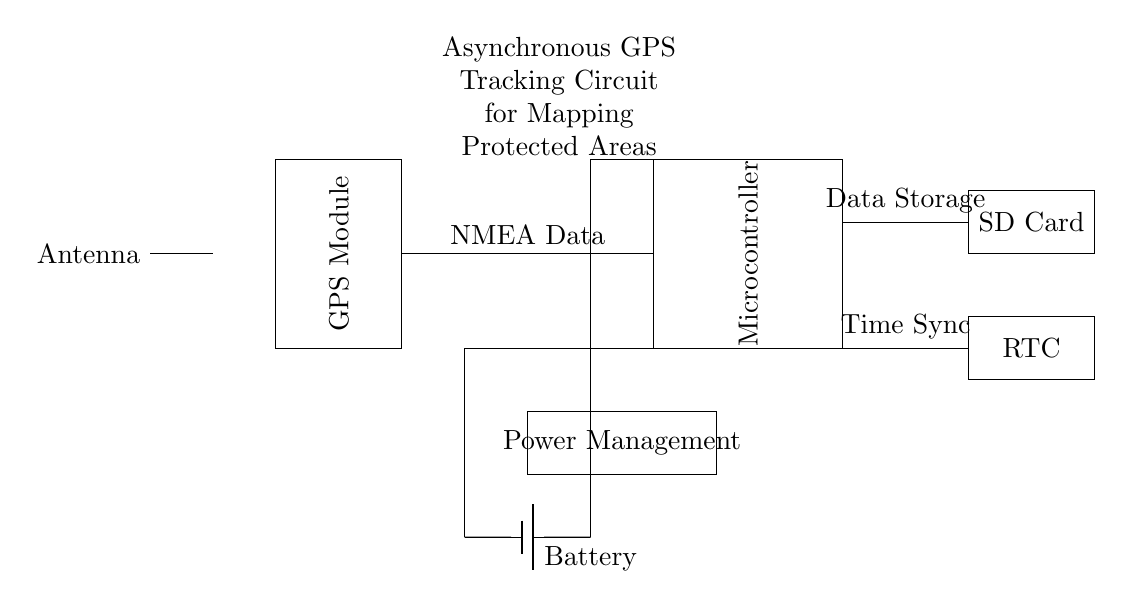What are the main components of the circuit? The main components visible in the circuit are the GPS Module, Microcontroller, Battery, Antenna, SD Card, RTC, and Power Management. These components are all drawn in rectangles and are labeled accordingly in the diagram.
Answer: GPS Module, Microcontroller, Battery, Antenna, SD Card, RTC, Power Management What type of power source is used in this circuit? The circuit diagram indicates a Battery, which is typically used as a power source in mobile or remote applications like this one. It is marked with a battery symbol in the diagram.
Answer: Battery How is data from the GPS Module transmitted to the Microcontroller? The diagram shows a direct line labeled NMEA Data connecting the GPS Module to the Microcontroller, indicating that the data transfer occurs through this connection interface using the NMEA format.
Answer: NMEA Data What is the role of the SD Card in this circuit? The SD Card is specifically labeled for Data Storage, indicating that it serves the purpose of storing the positioning data collected from the GPS module for later retrieval, which is crucial for mapping protected areas.
Answer: Data Storage How does the Real-Time Clock synchronize with the Microcontroller? The diagram indicates a connection labeled Time Sync going from the Microcontroller to the RTC, meaning that the Microcontroller sends synchronization signals to the RTC to maintain accurate time for time-stamping the GPS data.
Answer: Time Sync What is the function of the Power Management component in the circuit? The Power Management section regulates and distributes power from the Battery to the various components of the circuit, ensuring that each component receives the appropriate voltage and current as needed for operation.
Answer: Regulates power 